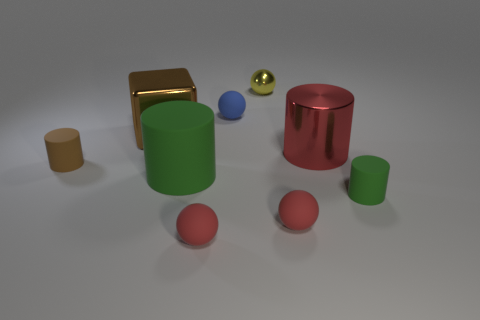What size is the other red thing that is the same shape as the big matte thing?
Make the answer very short. Large. Are there fewer large red objects left of the metallic cylinder than small blue balls?
Provide a succinct answer. Yes. Is the shape of the tiny blue rubber object the same as the yellow object?
Give a very brief answer. Yes. There is a small metallic thing that is the same shape as the tiny blue rubber thing; what color is it?
Provide a short and direct response. Yellow. How many tiny objects are the same color as the big metallic block?
Offer a very short reply. 1. How many objects are green rubber cylinders that are right of the big metal cylinder or big cyan balls?
Make the answer very short. 1. What size is the shiny block that is in front of the tiny blue ball?
Your answer should be compact. Large. Are there fewer green rubber cylinders than red metallic things?
Your answer should be compact. No. Do the brown thing that is on the right side of the small brown rubber object and the red thing that is behind the small green object have the same material?
Make the answer very short. Yes. What is the shape of the brown object behind the tiny rubber cylinder left of the big metal object to the right of the blue rubber object?
Your answer should be compact. Cube. 